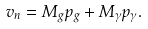<formula> <loc_0><loc_0><loc_500><loc_500>v _ { n } = M _ { g } p _ { g } + M _ { \gamma } p _ { \gamma } .</formula> 